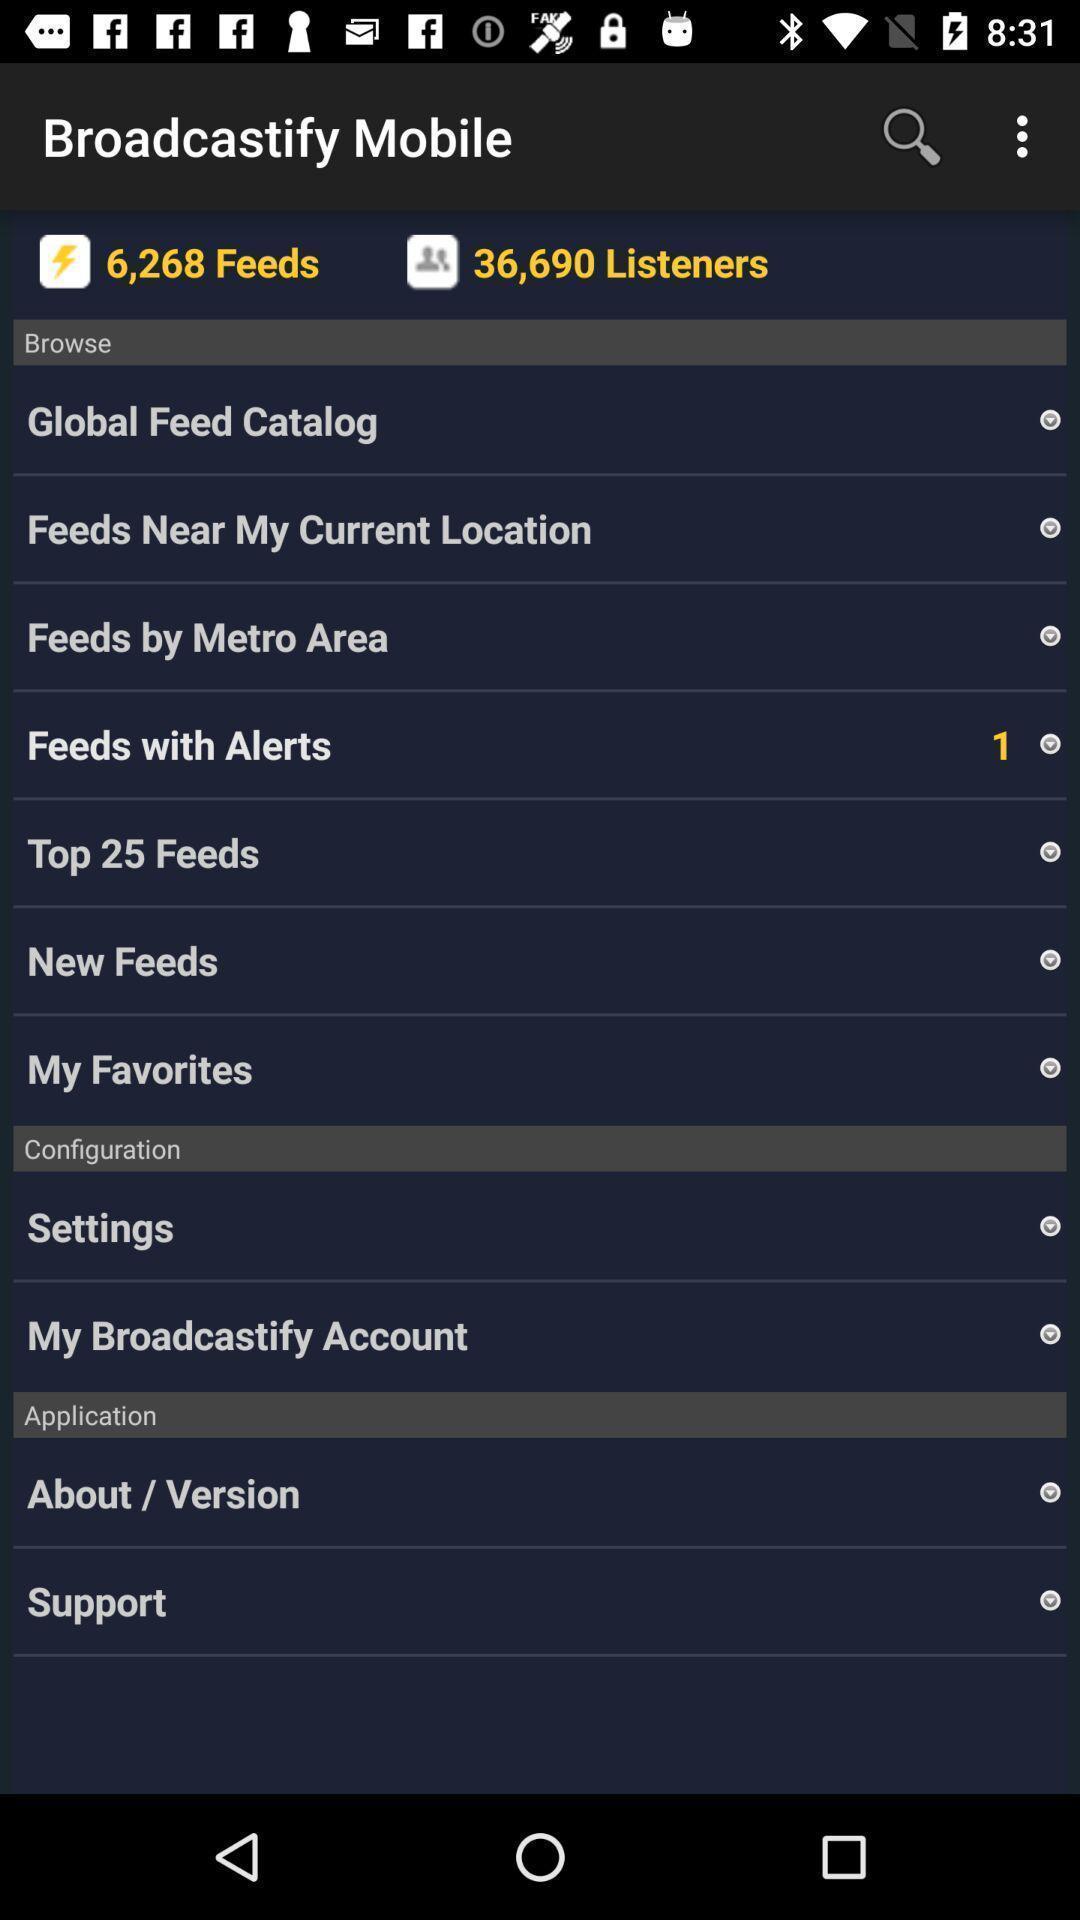Provide a description of this screenshot. Screen showing bowser options. 